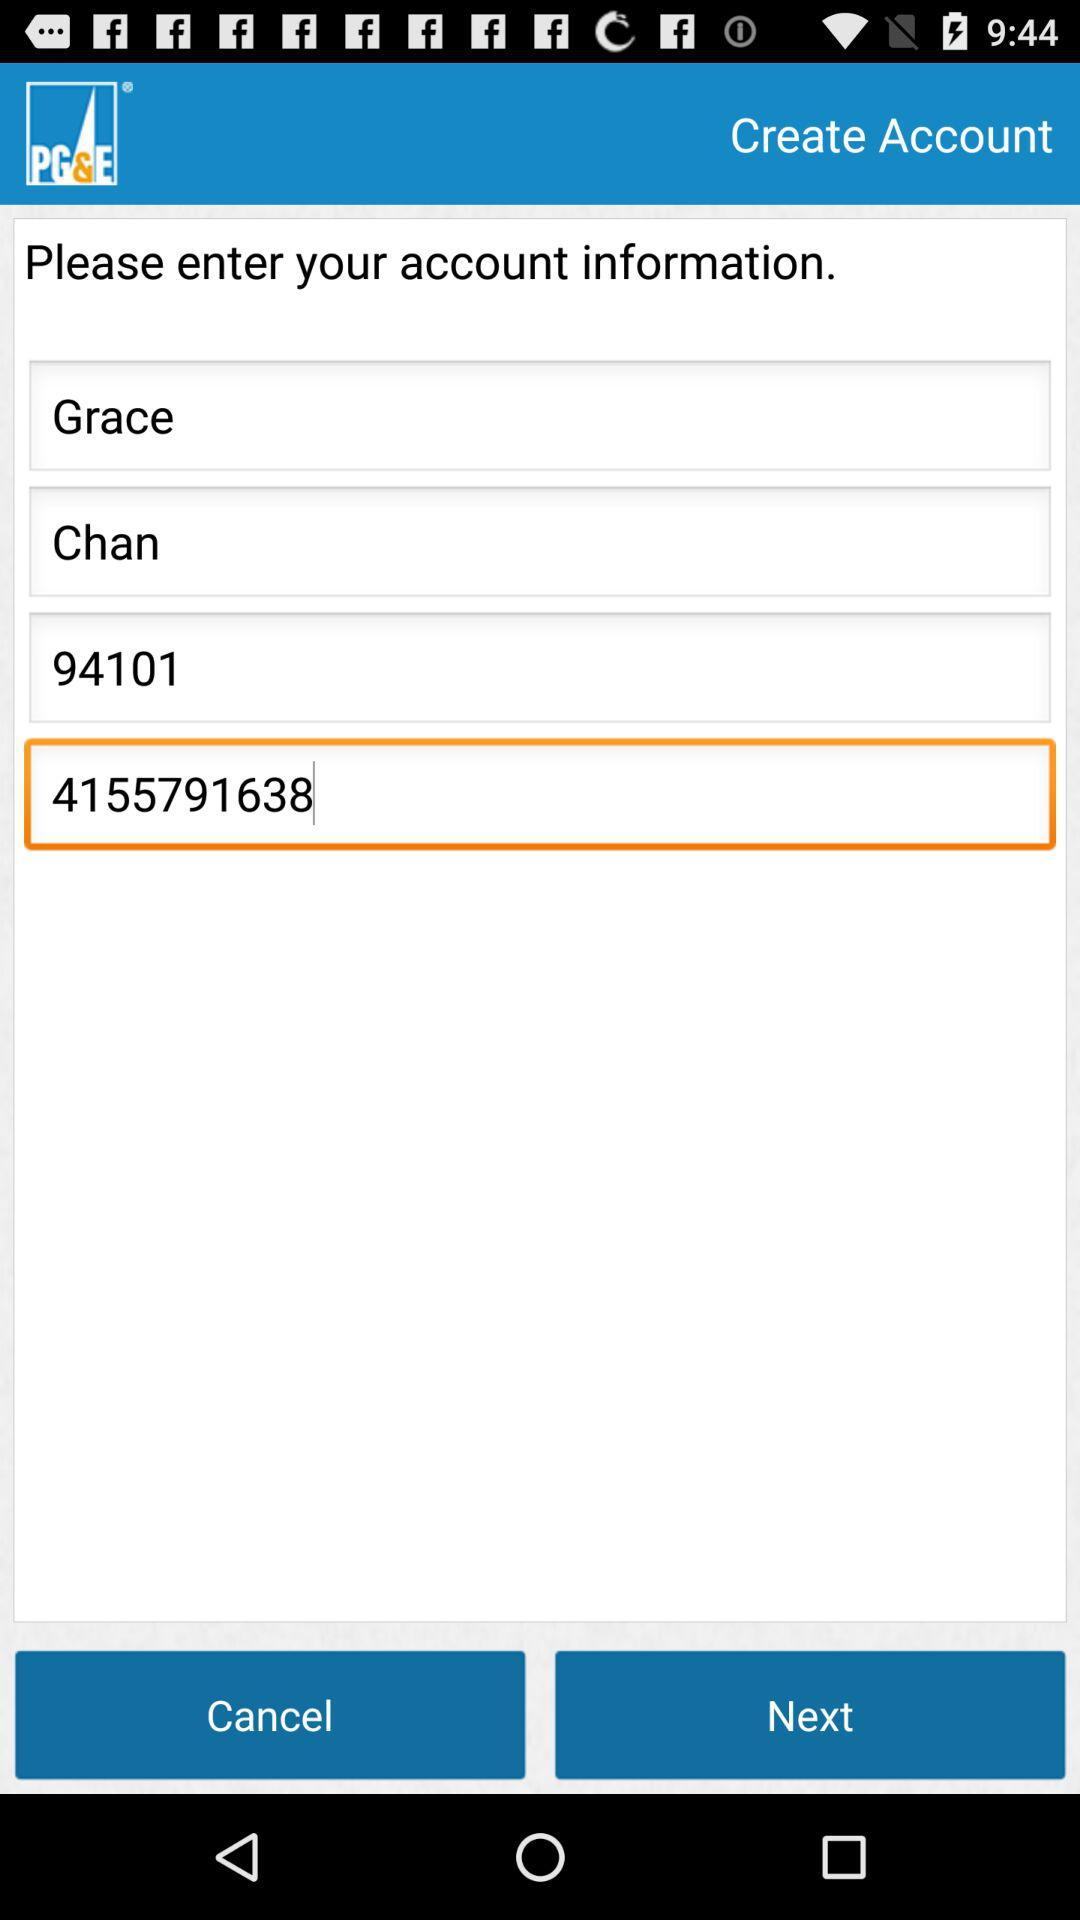What is the phone number? The phone number is 4155791638. 